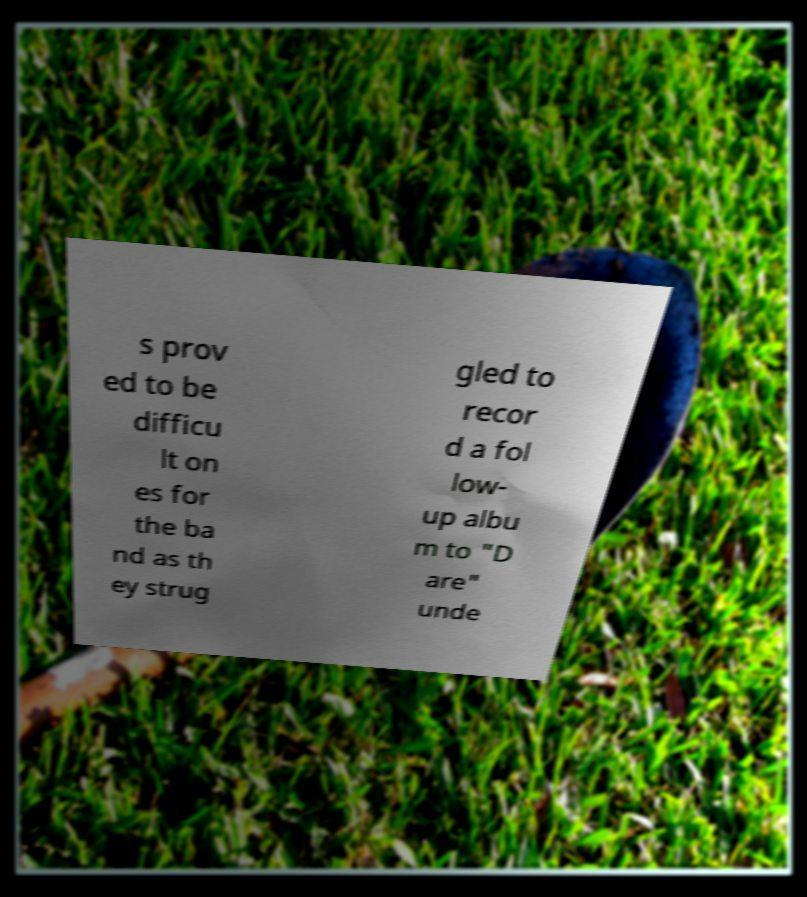Please identify and transcribe the text found in this image. s prov ed to be difficu lt on es for the ba nd as th ey strug gled to recor d a fol low- up albu m to "D are" unde 